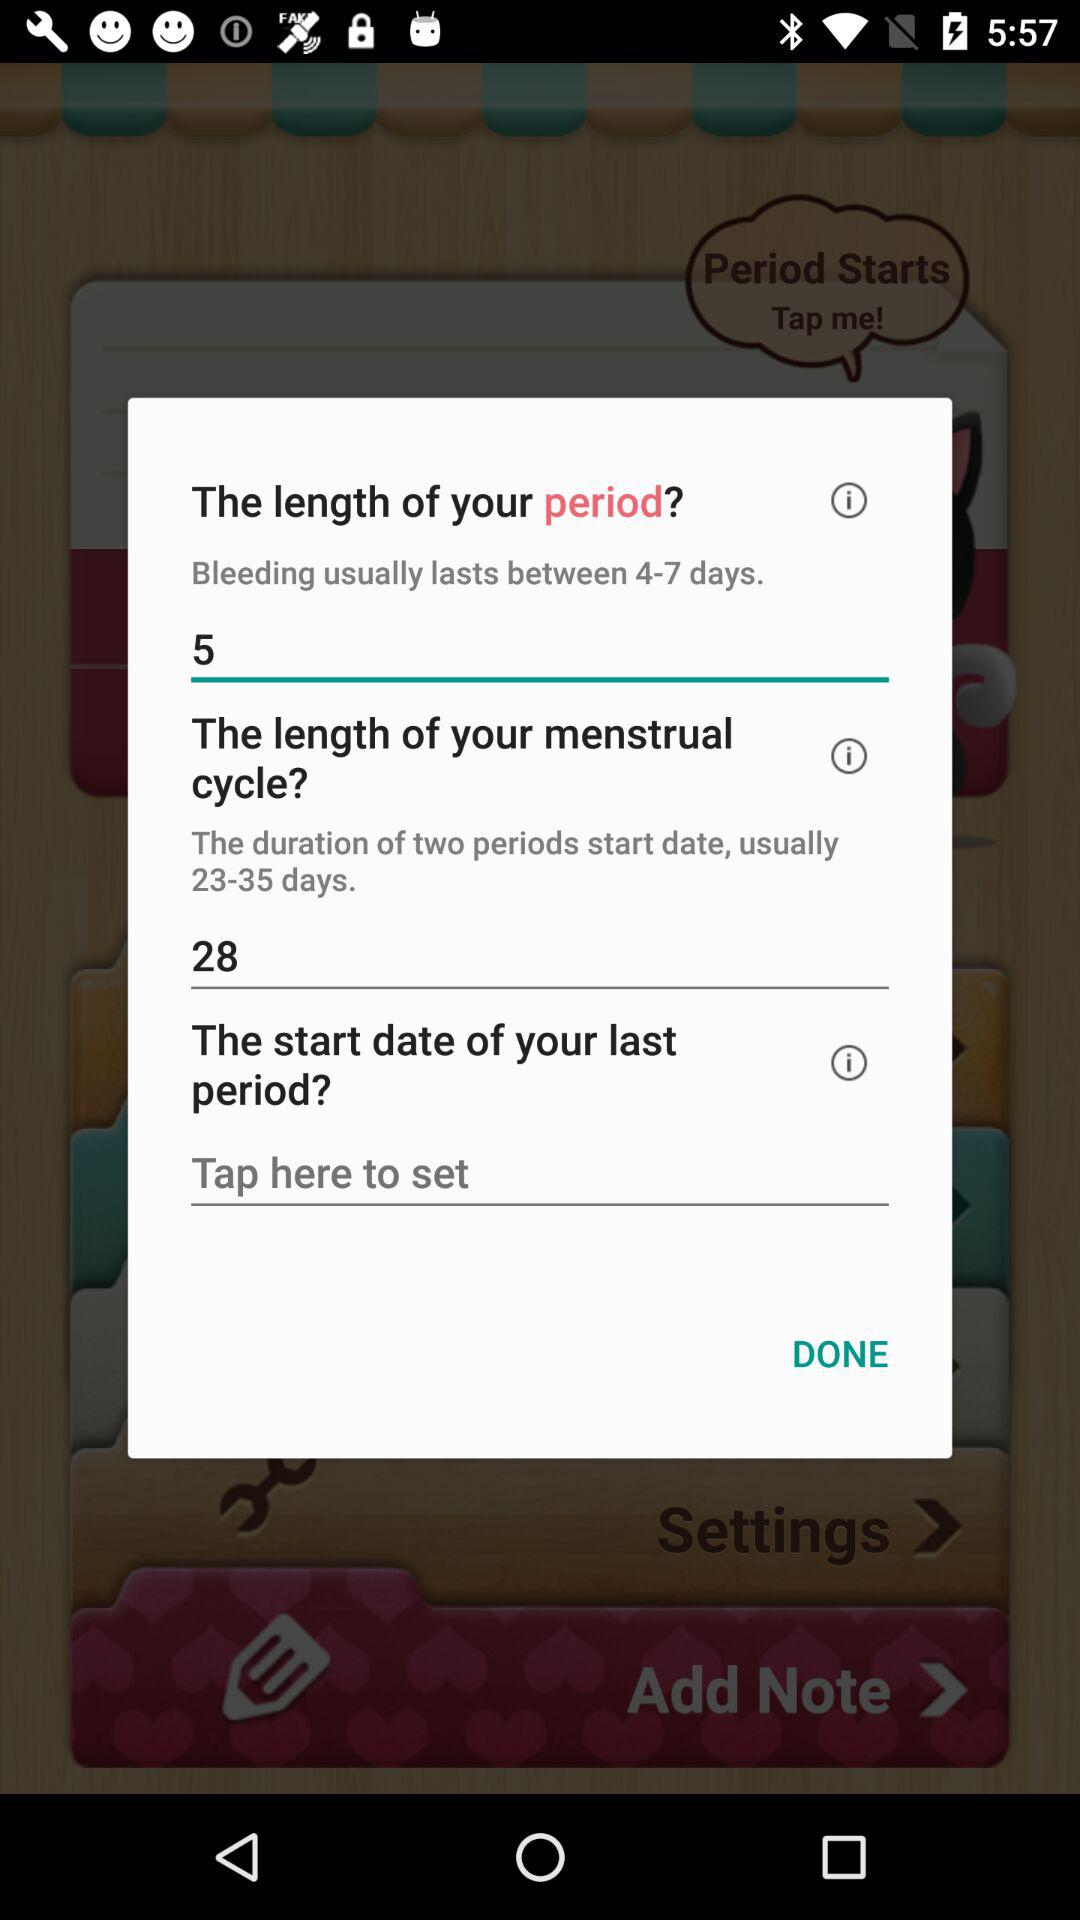For how many days does bleeding usually last? Bleeding usually lasts between 4 to 7 days. 